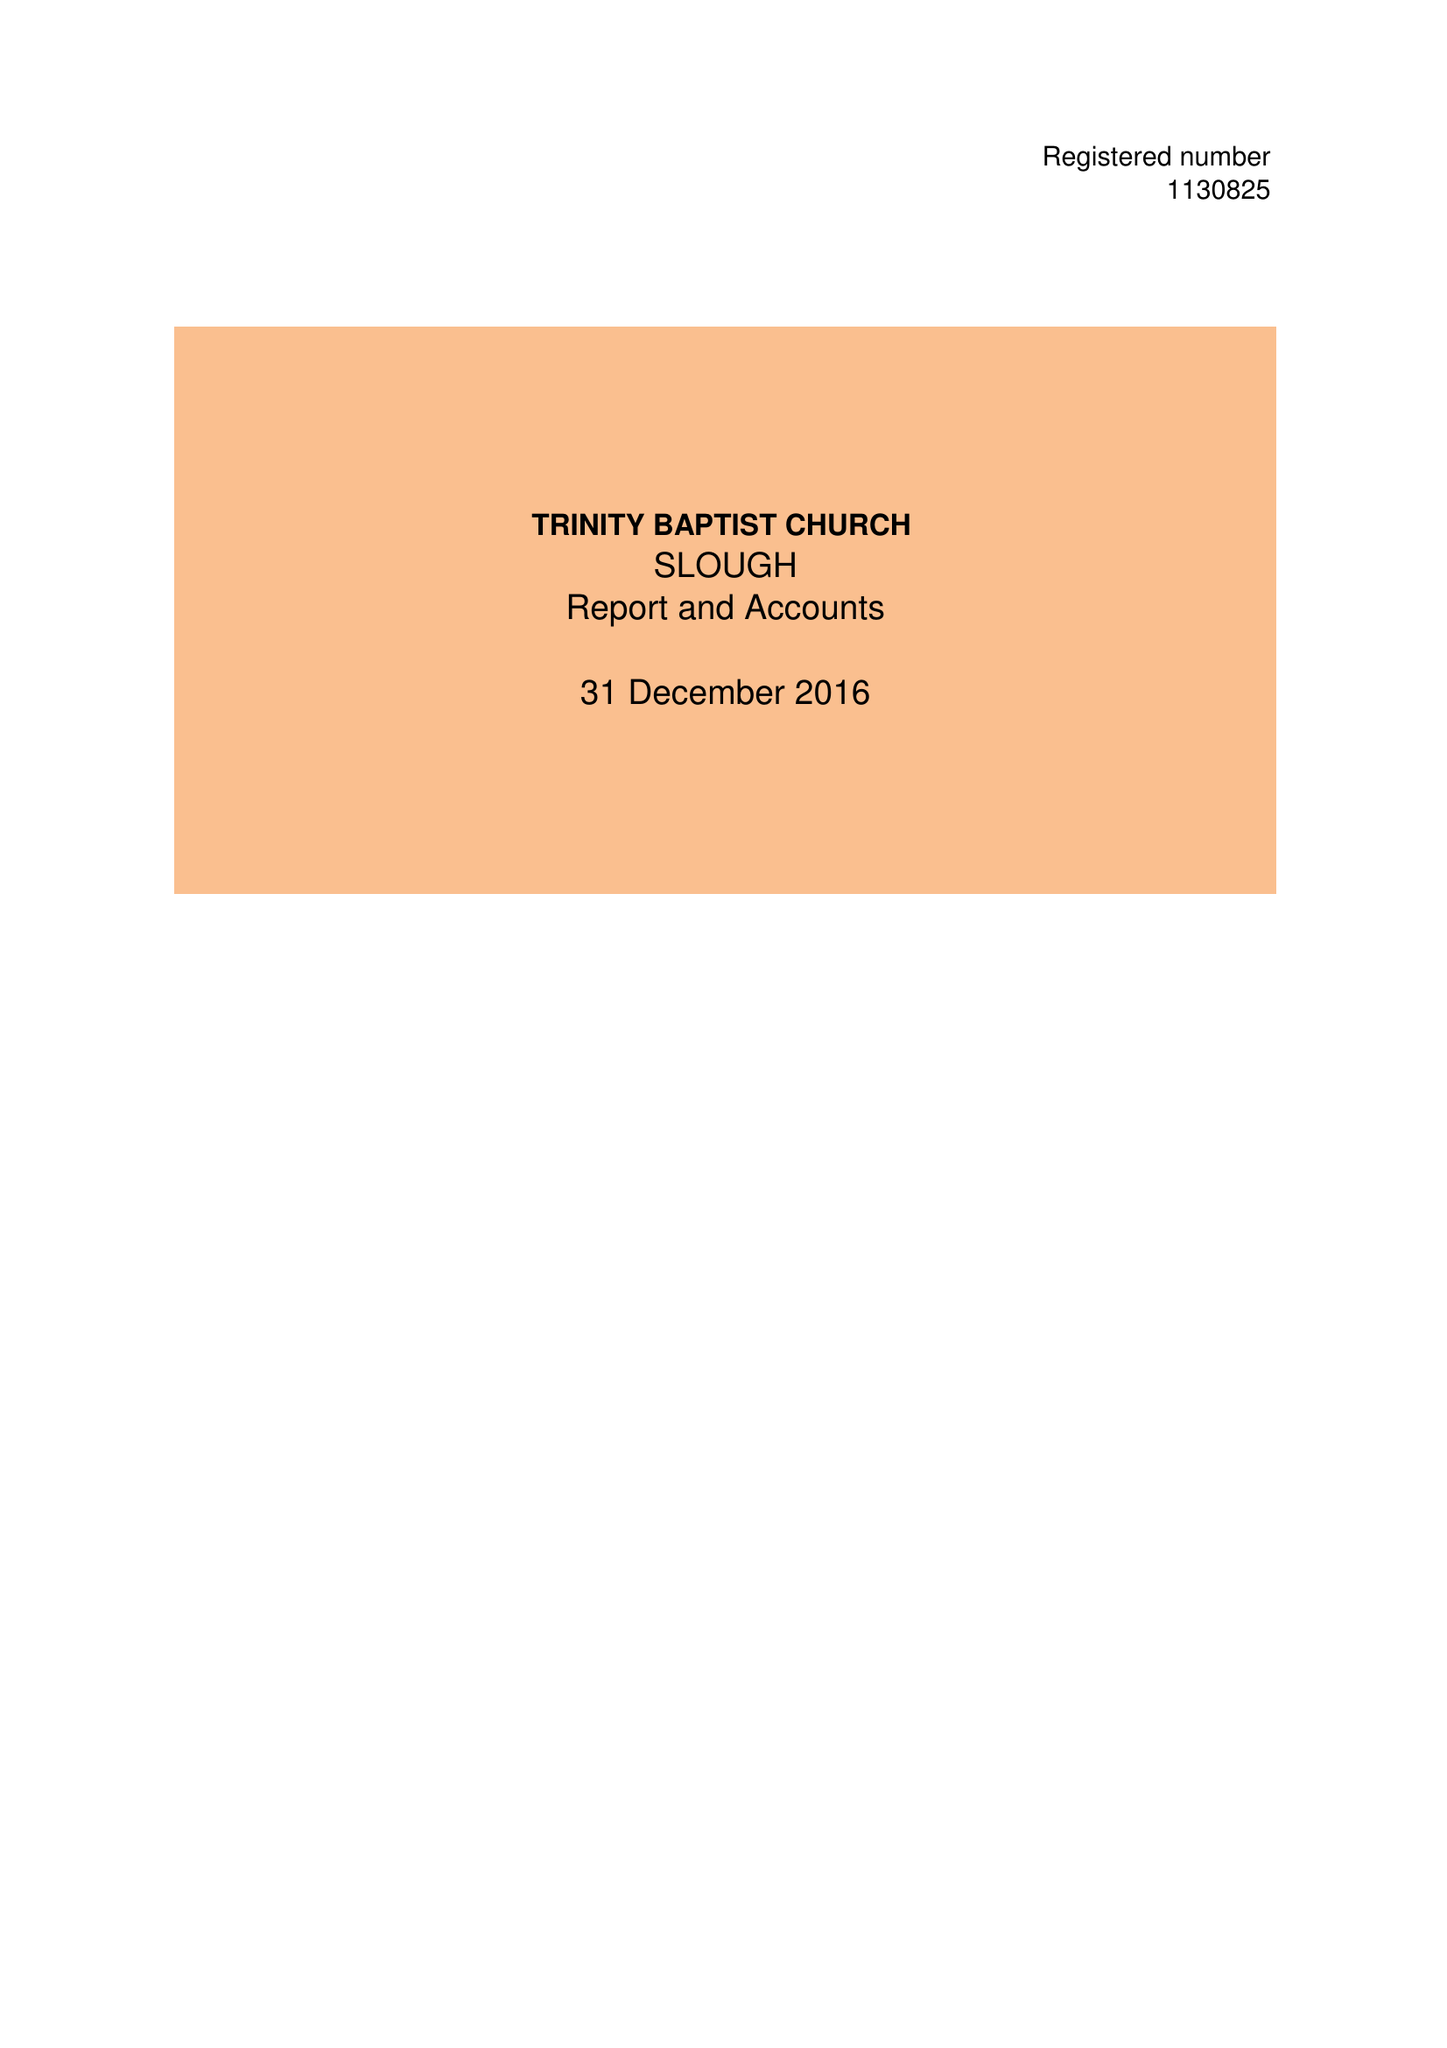What is the value for the charity_number?
Answer the question using a single word or phrase. 1130825 